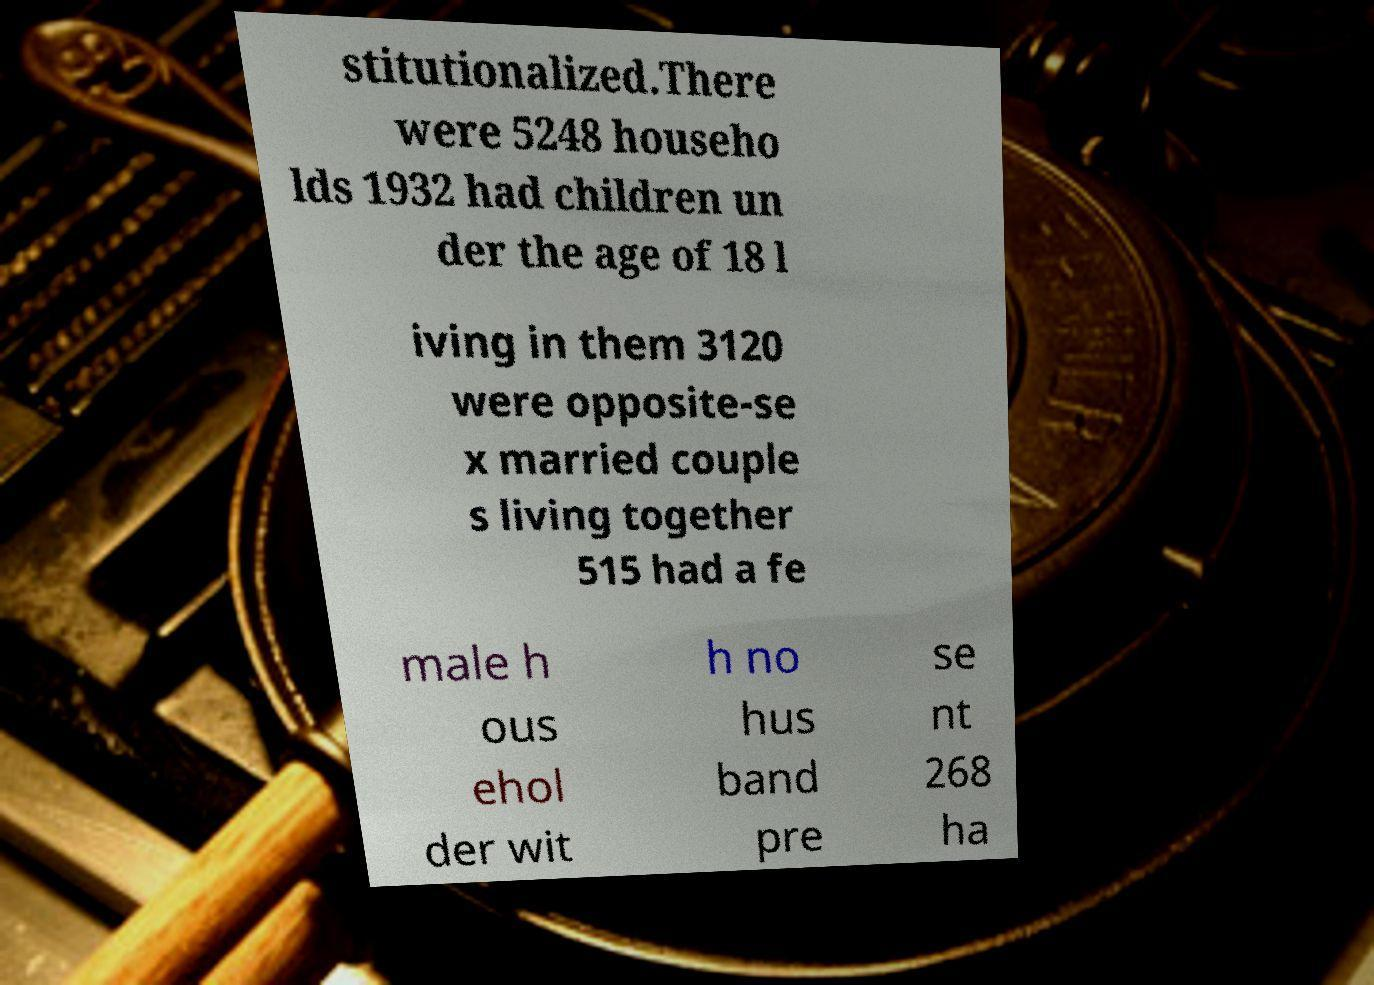What messages or text are displayed in this image? I need them in a readable, typed format. stitutionalized.There were 5248 househo lds 1932 had children un der the age of 18 l iving in them 3120 were opposite-se x married couple s living together 515 had a fe male h ous ehol der wit h no hus band pre se nt 268 ha 